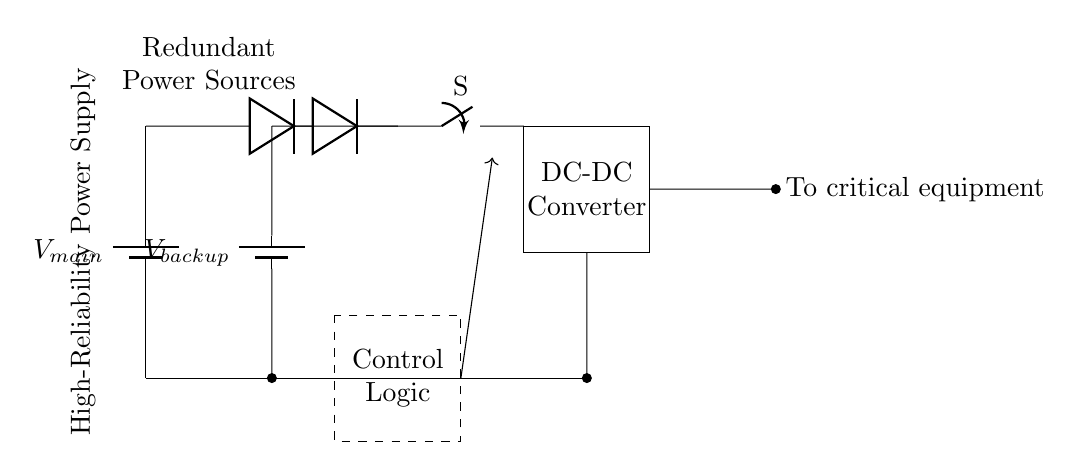What are the main power sources in this circuit? The circuit uses two batteries labeled as V_main and V_backup, which serve as the primary and backup power sources, respectively.
Answer: V_main, V_backup What component ensures isolation between the power sources? The circuit features two diodes connected in such a way that they allow current to flow from the batteries to the common output while preventing backflow from one battery to the other, thus ensuring isolation.
Answer: Diodes What is the purpose of the automatic transfer switch? The automatic transfer switch is designed to seamlessly switch between the main and backup power sources when one source fails or is unavailable, ensuring continuous power supply to the critical equipment.
Answer: Transfer switch How many power sources are connected to the switch? The switch connects two power sources: V_main from the main battery and V_backup from the backup battery, allowing it to choose the active source based on availability.
Answer: Two What component converts the voltage before it reaches the critical equipment? The circuit includes a DC-DC converter that adjusts the voltage level suitable for the critical equipment after the automatic transfer switch selects the active power source.
Answer: DC-DC converter What does the control logic regulate in this circuit? The control logic is responsible for monitoring the status of the power sources and the circuit's operational state, determining whether to engage the automatic transfer switch, ensuring reliable power to the critical equipment.
Answer: Controls the automatic switch 